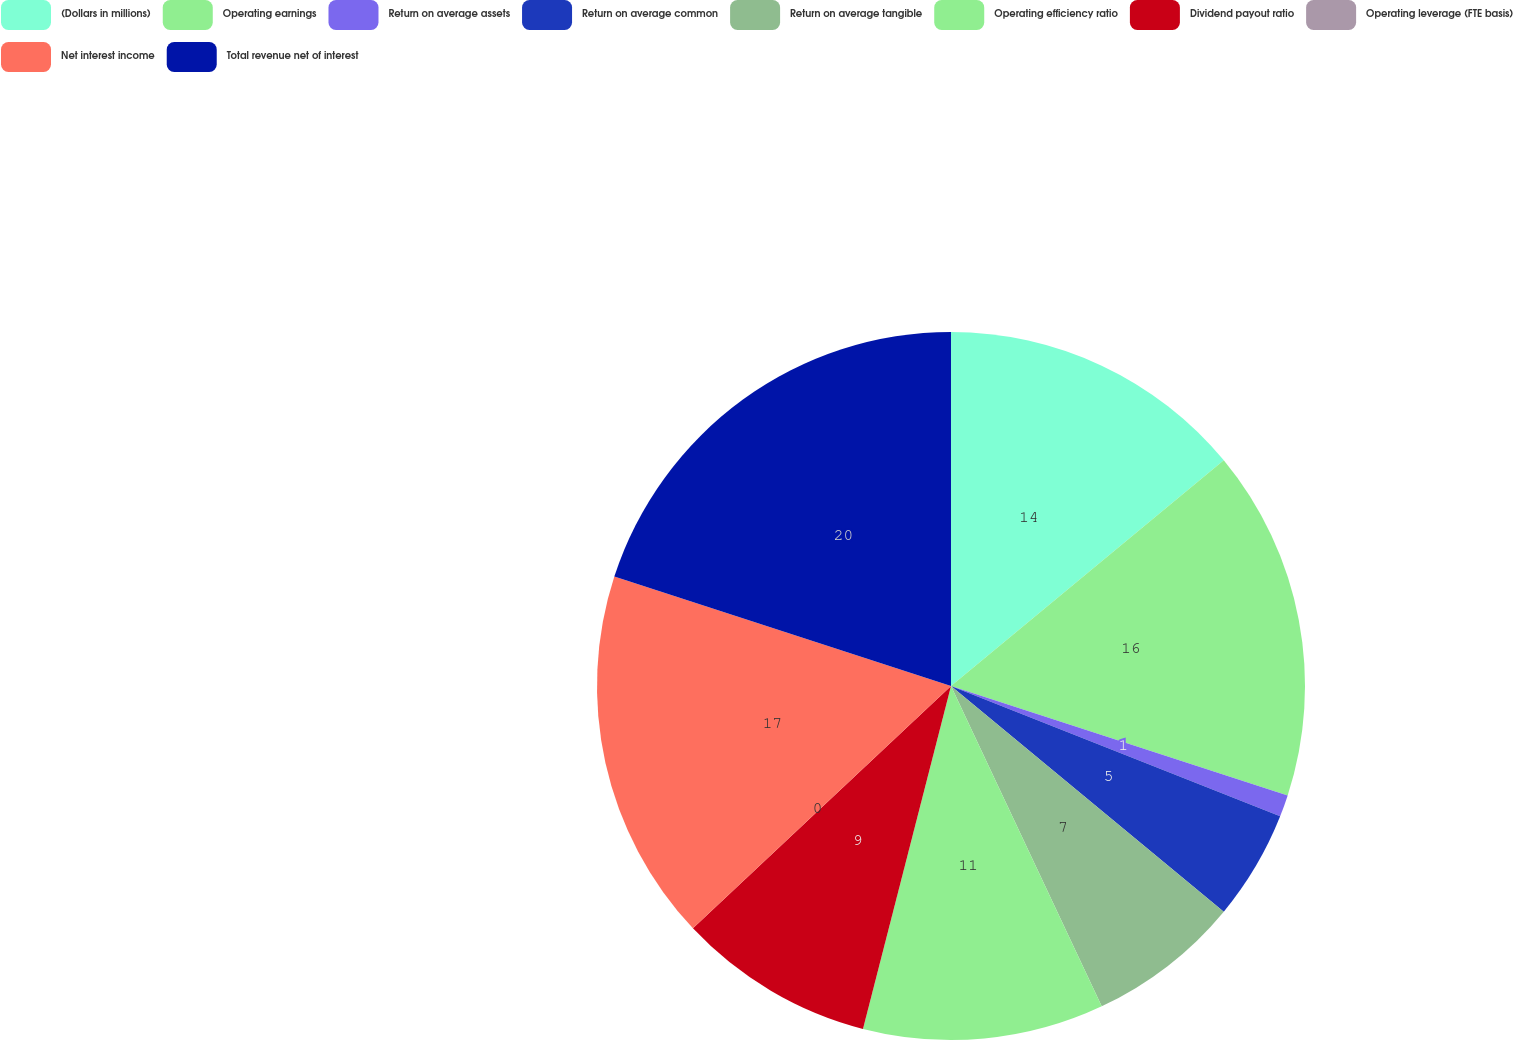Convert chart. <chart><loc_0><loc_0><loc_500><loc_500><pie_chart><fcel>(Dollars in millions)<fcel>Operating earnings<fcel>Return on average assets<fcel>Return on average common<fcel>Return on average tangible<fcel>Operating efficiency ratio<fcel>Dividend payout ratio<fcel>Operating leverage (FTE basis)<fcel>Net interest income<fcel>Total revenue net of interest<nl><fcel>14.0%<fcel>16.0%<fcel>1.0%<fcel>5.0%<fcel>7.0%<fcel>11.0%<fcel>9.0%<fcel>0.0%<fcel>17.0%<fcel>20.0%<nl></chart> 